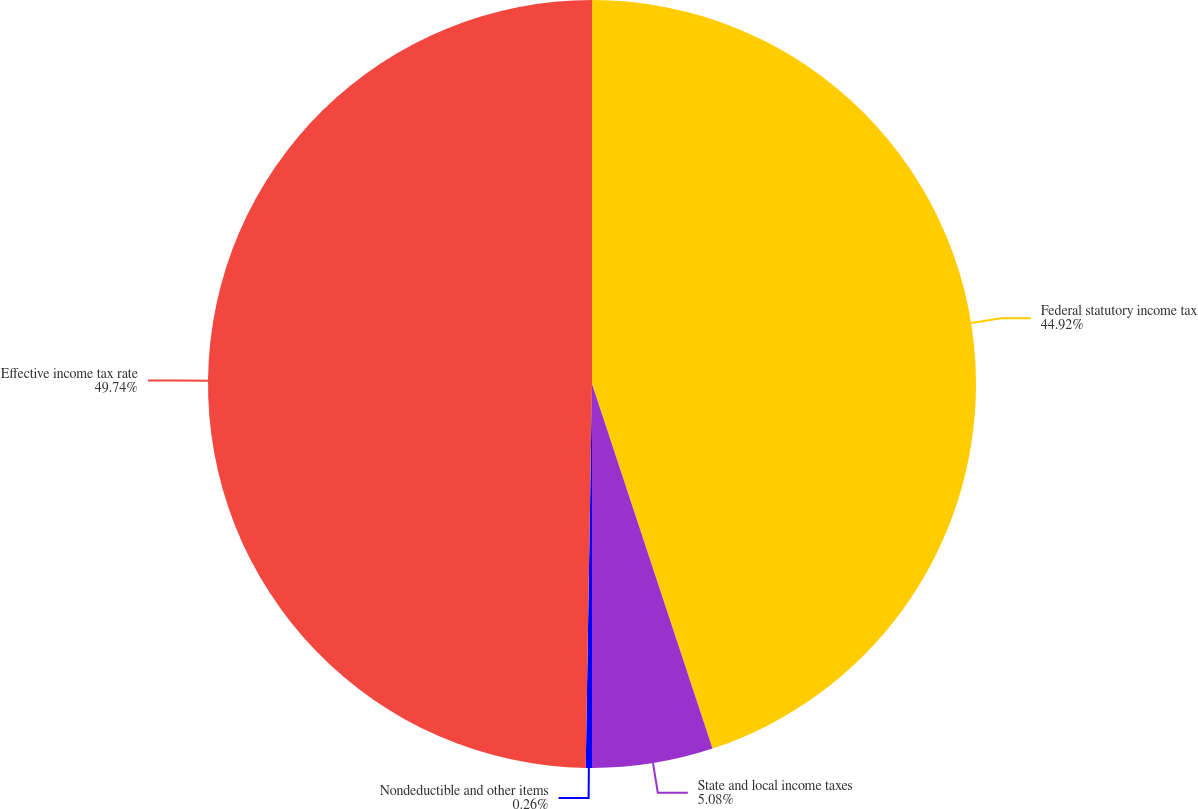Convert chart. <chart><loc_0><loc_0><loc_500><loc_500><pie_chart><fcel>Federal statutory income tax<fcel>State and local income taxes<fcel>Nondeductible and other items<fcel>Effective income tax rate<nl><fcel>44.92%<fcel>5.08%<fcel>0.26%<fcel>49.74%<nl></chart> 